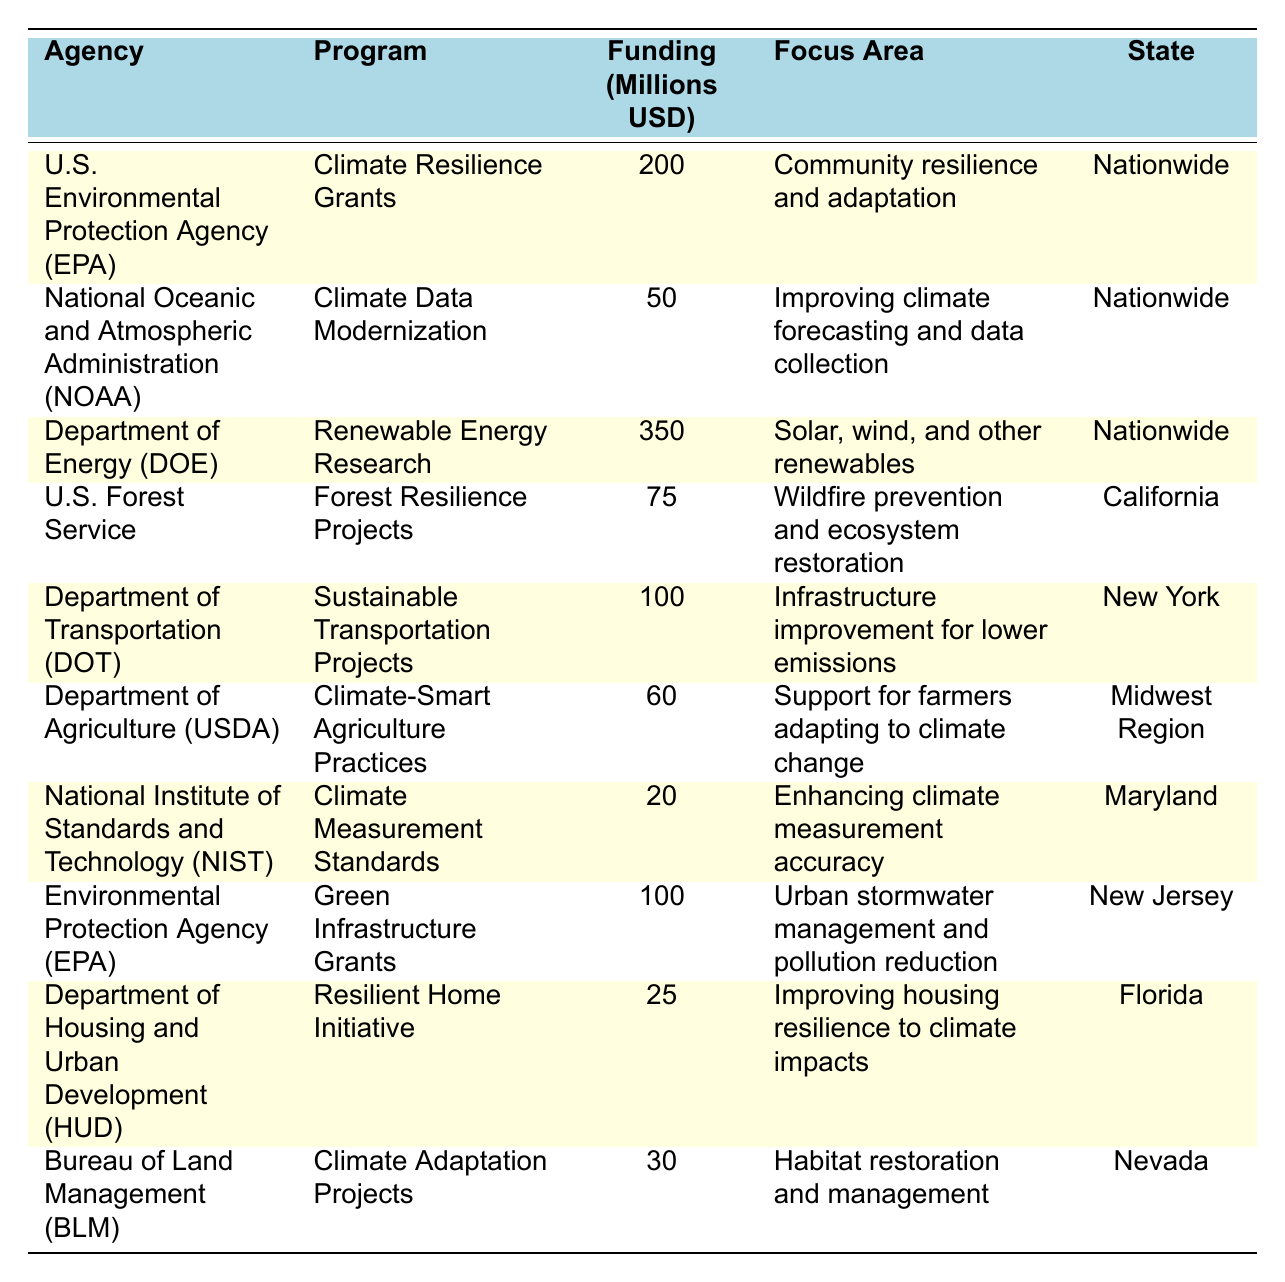What is the total funding amount allocated to the Department of Energy? The table shows that the Department of Energy allocated $350 million for Renewable Energy Research.
Answer: 350 million Which agency has the highest funding amount, and what is that amount? The Department of Energy has the highest funding amount of $350 million, allocated for Renewable Energy Research.
Answer: Department of Energy, 350 million How much funding was allocated for climate resilience and adaptation programs? The U.S. Environmental Protection Agency allocated $200 million for Climate Resilience Grants, and the total for resilience programs is $200 million.
Answer: 200 million Is there a program focused on improving housing resilience? Yes, the Department of Housing and Urban Development has a program called Resilient Home Initiative, which focuses on improving housing resilience with a funding of $25 million.
Answer: Yes What is the funding difference between the Nature Conservation Projects by the U.S. Forest Service and the Sustainable Transportation Projects by the Department of Transportation? The U.S. Forest Service allocated $75 million for Forest Resilience Projects, and the Department of Transportation allocated $100 million for Sustainable Transportation Projects. The difference is $100 million - $75 million = $25 million.
Answer: 25 million Which state received funding for urban stormwater management and pollution reduction? The Environmental Protection Agency allocated $100 million for Green Infrastructure Grants, which focuses on urban stormwater management and pollution reduction, specifically in New Jersey.
Answer: New Jersey What is the total funding amount for climate-related programs in California? The table indicates that the U.S. Forest Service allocated $75 million for Forest Resilience Projects in California. Since this is the only program listed for California in the table, the total is $75 million.
Answer: 75 million How many different agencies allocated funding for climate change programs? There are 10 entries in the table, indicating that 9 distinct agencies allocated funding for climate change programs (two entries for the EPA but counted as one agency).
Answer: 9 agencies Which program received the lowest funding, and what is the amount? The National Institute of Standards and Technology allocated $20 million for Climate Measurement Standards, which is the lowest announced funding in the table.
Answer: $20 million What percentage of the total funding for climate change programs is allocated to Renewable Energy Research? The total funding from the table sums to $1,150 million. The Department of Energy's Renewable Energy Research received $350 million, so the percentage is ($350 million / $1,150 million) * 100 = 30.43%.
Answer: 30.43% 